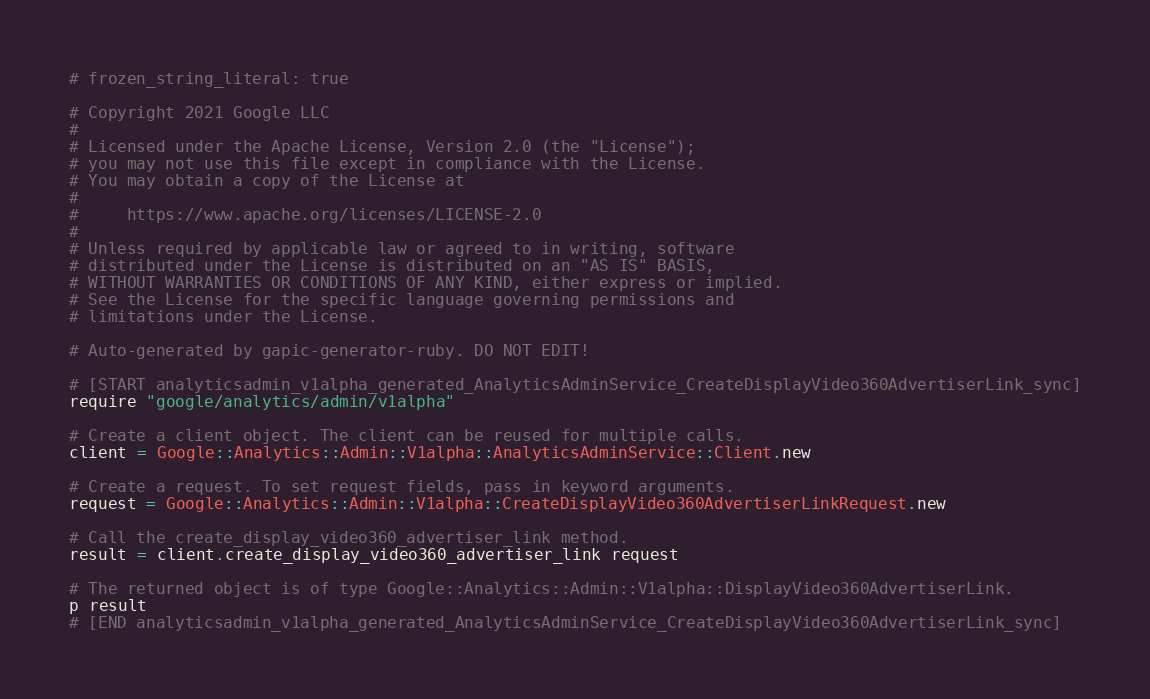Convert code to text. <code><loc_0><loc_0><loc_500><loc_500><_Ruby_># frozen_string_literal: true

# Copyright 2021 Google LLC
#
# Licensed under the Apache License, Version 2.0 (the "License");
# you may not use this file except in compliance with the License.
# You may obtain a copy of the License at
#
#     https://www.apache.org/licenses/LICENSE-2.0
#
# Unless required by applicable law or agreed to in writing, software
# distributed under the License is distributed on an "AS IS" BASIS,
# WITHOUT WARRANTIES OR CONDITIONS OF ANY KIND, either express or implied.
# See the License for the specific language governing permissions and
# limitations under the License.

# Auto-generated by gapic-generator-ruby. DO NOT EDIT!

# [START analyticsadmin_v1alpha_generated_AnalyticsAdminService_CreateDisplayVideo360AdvertiserLink_sync]
require "google/analytics/admin/v1alpha"

# Create a client object. The client can be reused for multiple calls.
client = Google::Analytics::Admin::V1alpha::AnalyticsAdminService::Client.new

# Create a request. To set request fields, pass in keyword arguments.
request = Google::Analytics::Admin::V1alpha::CreateDisplayVideo360AdvertiserLinkRequest.new

# Call the create_display_video360_advertiser_link method.
result = client.create_display_video360_advertiser_link request

# The returned object is of type Google::Analytics::Admin::V1alpha::DisplayVideo360AdvertiserLink.
p result
# [END analyticsadmin_v1alpha_generated_AnalyticsAdminService_CreateDisplayVideo360AdvertiserLink_sync]
</code> 